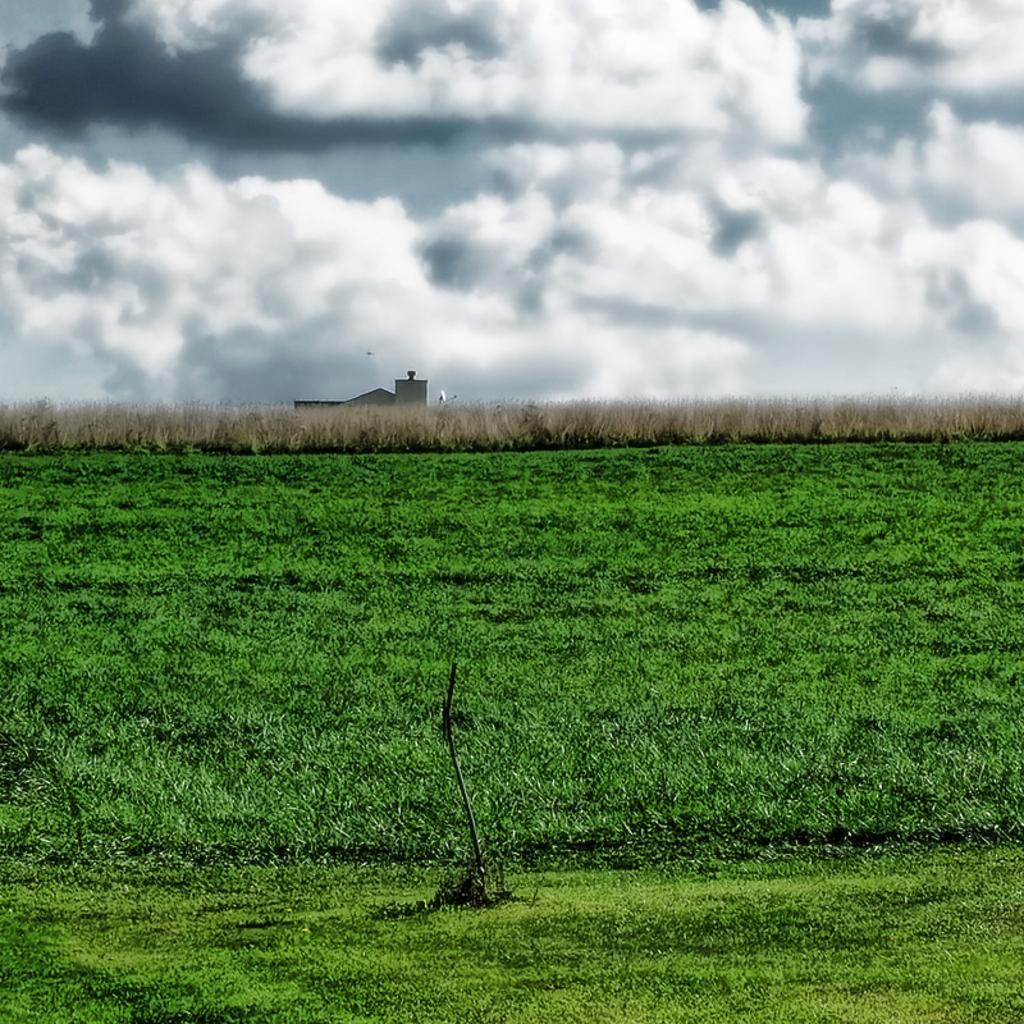What type of vegetation is visible in the image? There is grass in the image. What else can be seen in the background of the image? There are plants and a house in the background of the image. How would you describe the sky in the image? The sky is cloudy in the image. What type of root can be seen growing from the house in the image? There is no root growing from the house in the image; it is a solid structure. 